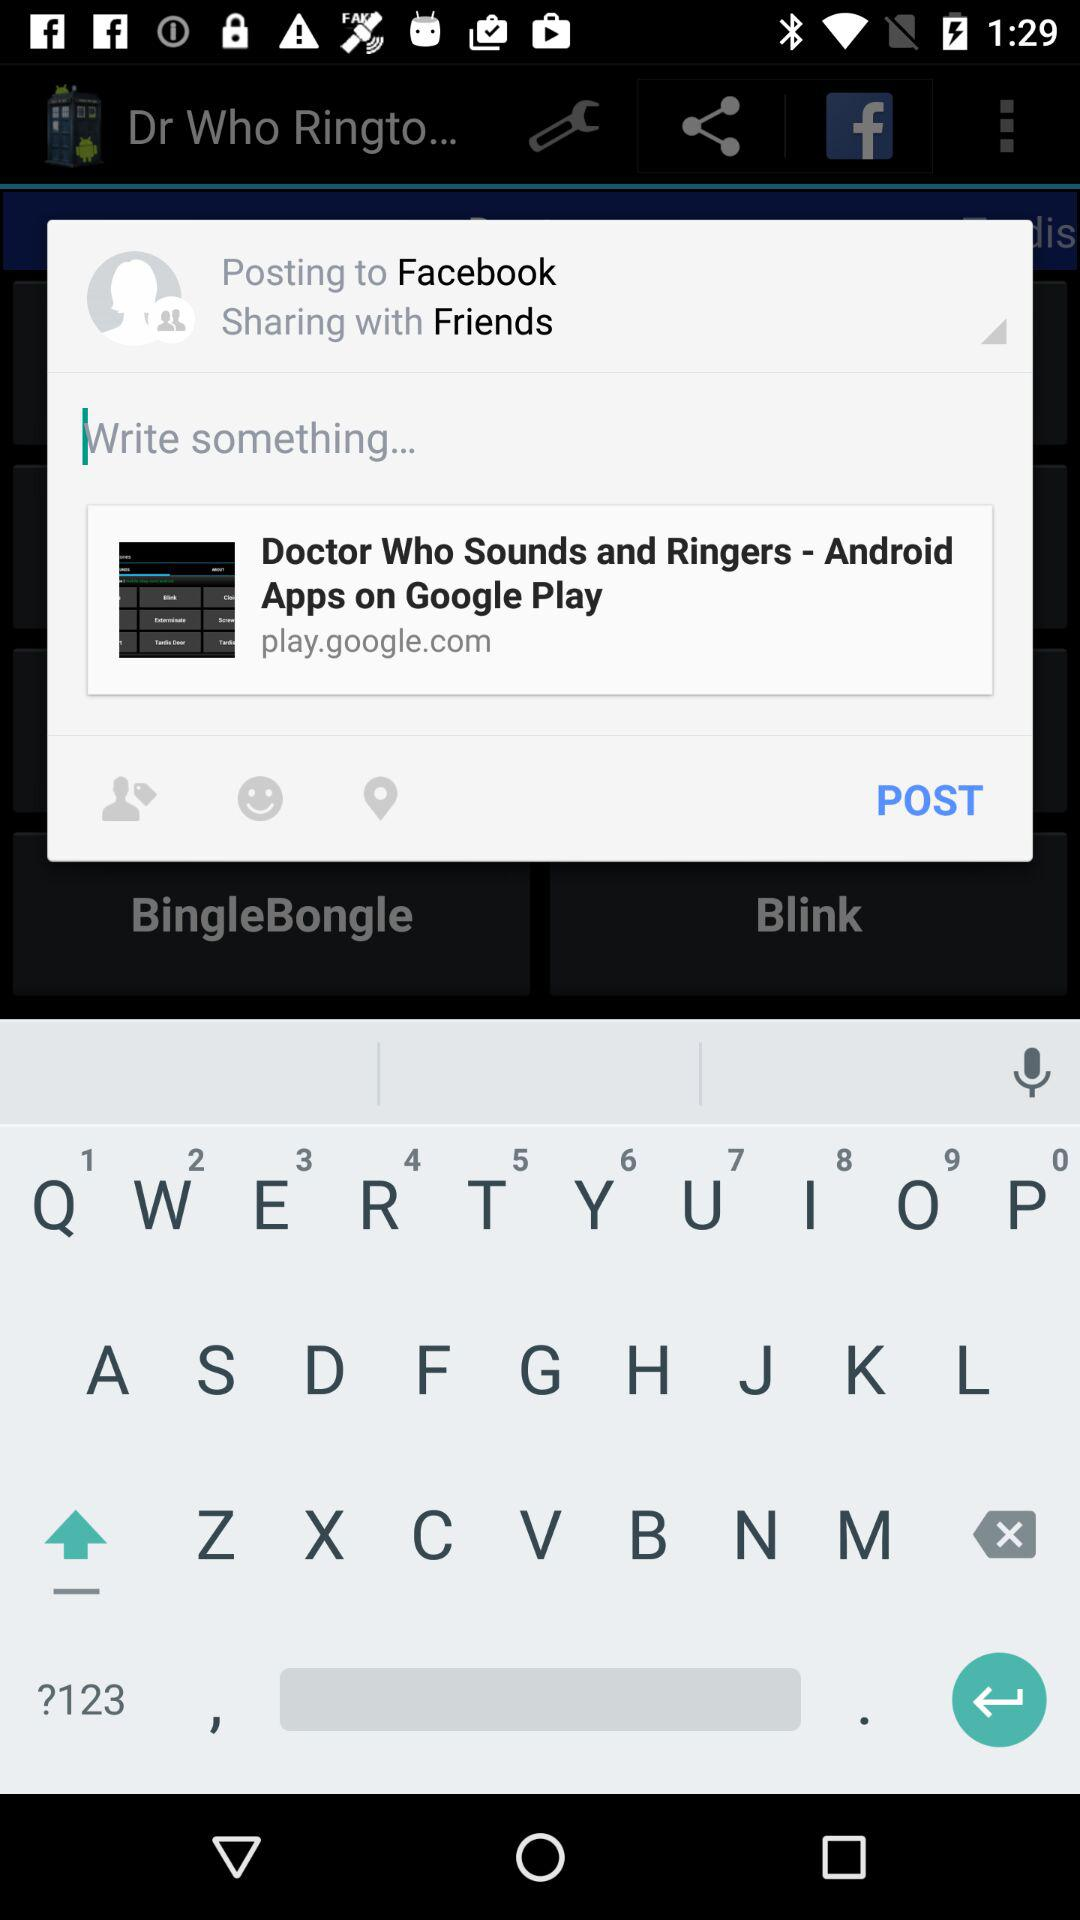What is the name of the application? The name of the application is "Dr Who Ringtones". 